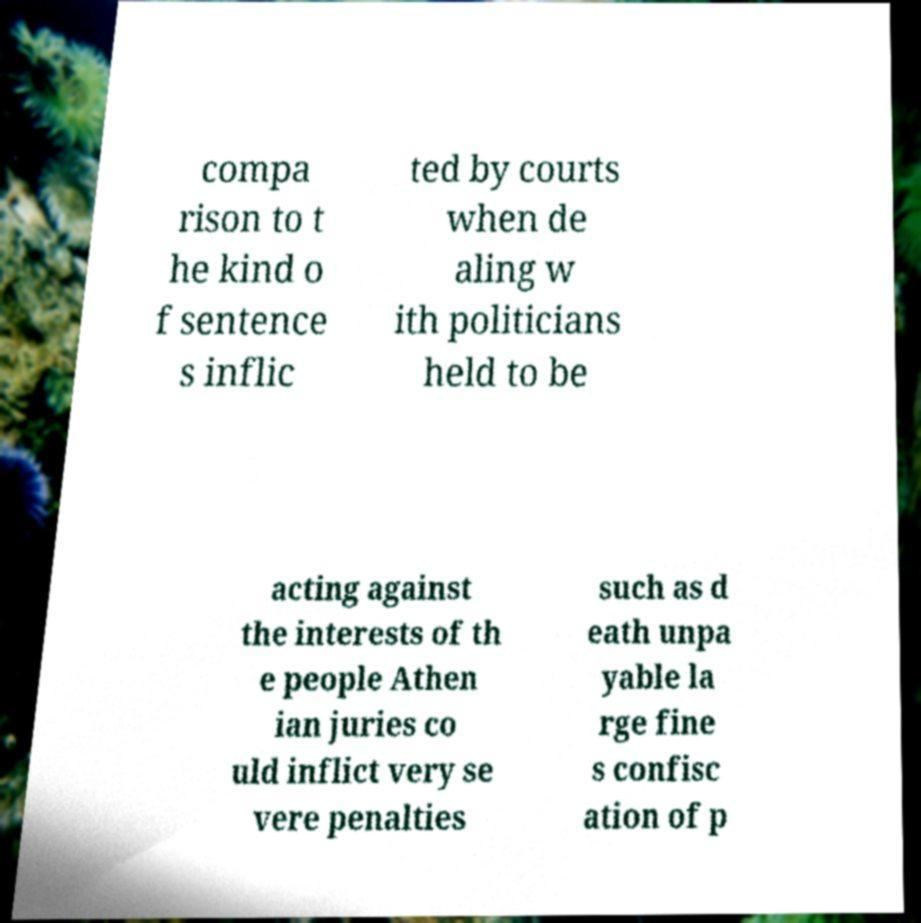Please read and relay the text visible in this image. What does it say? compa rison to t he kind o f sentence s inflic ted by courts when de aling w ith politicians held to be acting against the interests of th e people Athen ian juries co uld inflict very se vere penalties such as d eath unpa yable la rge fine s confisc ation of p 